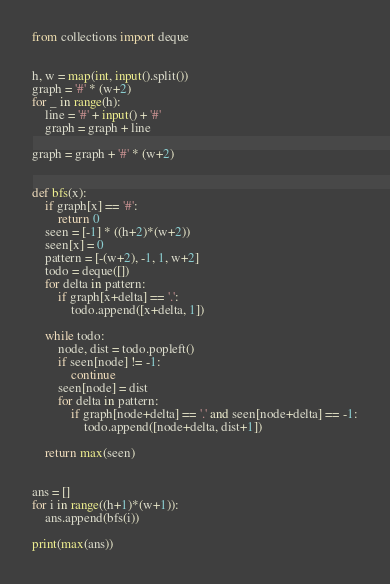<code> <loc_0><loc_0><loc_500><loc_500><_Python_>from collections import deque


h, w = map(int, input().split())
graph = '#' * (w+2)
for _ in range(h):
    line = '#' + input() + '#'
    graph = graph + line

graph = graph + '#' * (w+2)


def bfs(x):
    if graph[x] == '#':
        return 0
    seen = [-1] * ((h+2)*(w+2))
    seen[x] = 0
    pattern = [-(w+2), -1, 1, w+2]
    todo = deque([])
    for delta in pattern:
        if graph[x+delta] == '.':
            todo.append([x+delta, 1])

    while todo:
        node, dist = todo.popleft()
        if seen[node] != -1:
            continue
        seen[node] = dist
        for delta in pattern:
            if graph[node+delta] == '.' and seen[node+delta] == -1:
                todo.append([node+delta, dist+1])

    return max(seen)


ans = []
for i in range((h+1)*(w+1)):
    ans.append(bfs(i))

print(max(ans))</code> 